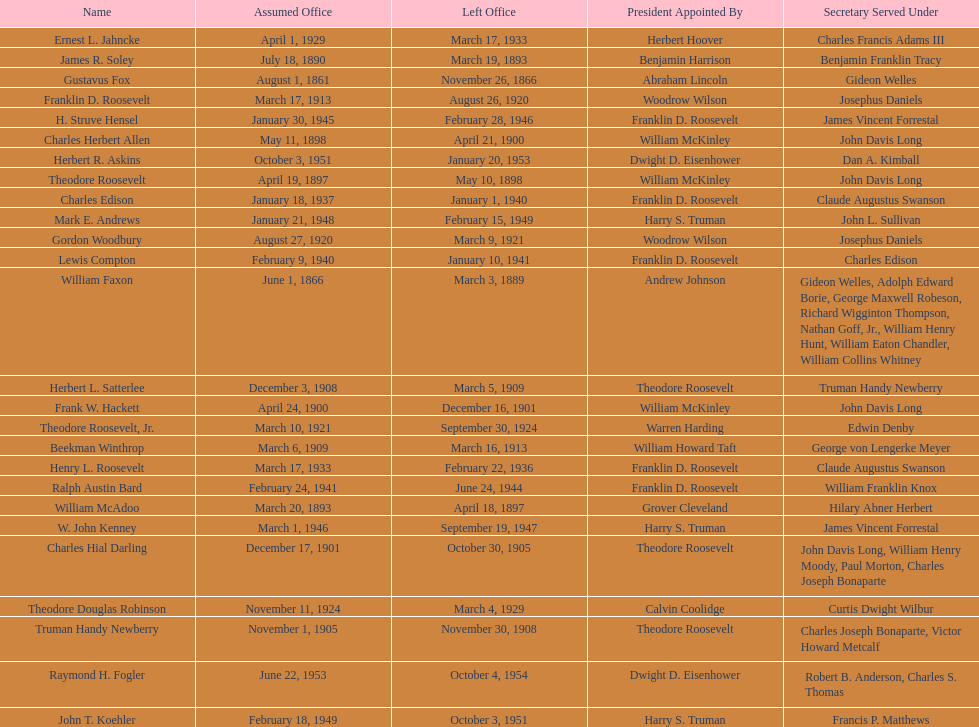Who was the first assistant secretary of the navy? Gustavus Fox. 